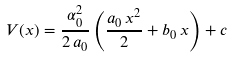<formula> <loc_0><loc_0><loc_500><loc_500>V ( x ) = \frac { \alpha _ { 0 } ^ { 2 } } { 2 \, a _ { 0 } } \left ( \frac { a _ { 0 } \, x ^ { 2 } } { 2 } + b _ { 0 } \, x \right ) + c</formula> 